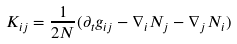<formula> <loc_0><loc_0><loc_500><loc_500>K _ { i j } = \frac { 1 } { 2 N } ( \partial _ { t } g _ { i j } - \nabla _ { i } N _ { j } - \nabla _ { j } N _ { i } )</formula> 